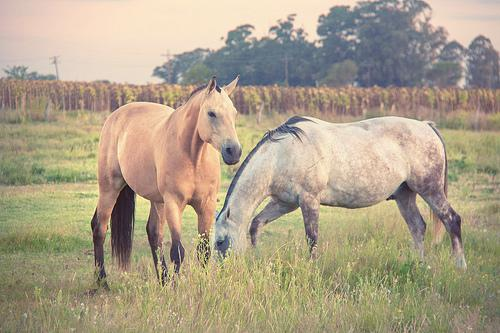Question: where was this photo taken?
Choices:
A. In a field.
B. At home.
C. At school.
D. By the car.
Answer with the letter. Answer: A Question: how many horses are there?
Choices:
A. 1.
B. 3.
C. 2.
D. 4.
Answer with the letter. Answer: C Question: what is on the ground?
Choices:
A. Leaves.
B. Grass.
C. Flowers.
D. People.
Answer with the letter. Answer: B Question: why is the right horses head down?
Choices:
A. To sleep.
B. To run.
C. To drink.
D. To graze.
Answer with the letter. Answer: D 